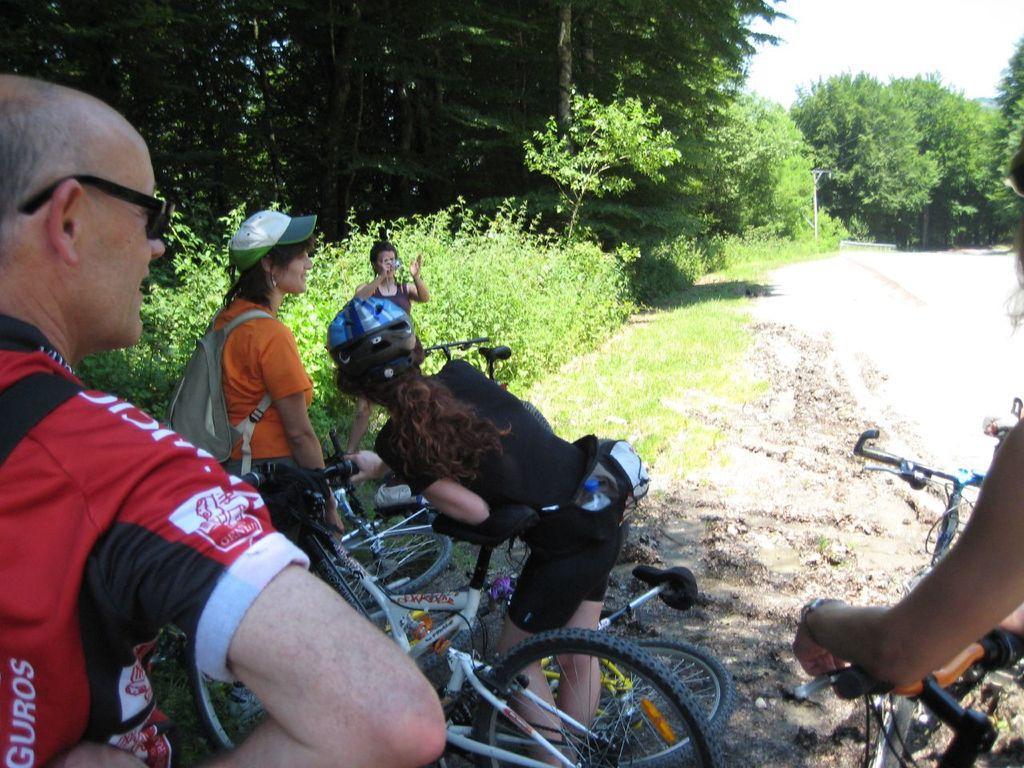Could you give a brief overview of what you see in this image? In this image we can see some trees, pole, walkway and some other objects. At the bottom of the image there are some persons and bicycles. In the background of the image there is the sky. 